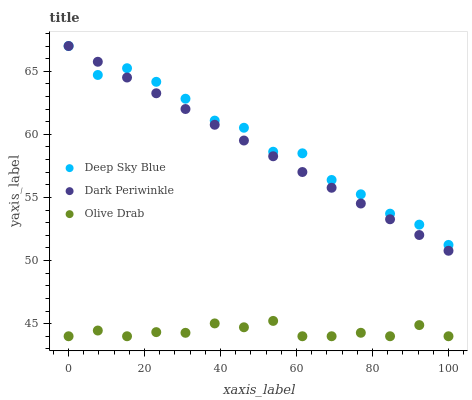Does Olive Drab have the minimum area under the curve?
Answer yes or no. Yes. Does Deep Sky Blue have the maximum area under the curve?
Answer yes or no. Yes. Does Dark Periwinkle have the minimum area under the curve?
Answer yes or no. No. Does Dark Periwinkle have the maximum area under the curve?
Answer yes or no. No. Is Dark Periwinkle the smoothest?
Answer yes or no. Yes. Is Deep Sky Blue the roughest?
Answer yes or no. Yes. Is Deep Sky Blue the smoothest?
Answer yes or no. No. Is Dark Periwinkle the roughest?
Answer yes or no. No. Does Olive Drab have the lowest value?
Answer yes or no. Yes. Does Dark Periwinkle have the lowest value?
Answer yes or no. No. Does Deep Sky Blue have the highest value?
Answer yes or no. Yes. Is Olive Drab less than Deep Sky Blue?
Answer yes or no. Yes. Is Dark Periwinkle greater than Olive Drab?
Answer yes or no. Yes. Does Deep Sky Blue intersect Dark Periwinkle?
Answer yes or no. Yes. Is Deep Sky Blue less than Dark Periwinkle?
Answer yes or no. No. Is Deep Sky Blue greater than Dark Periwinkle?
Answer yes or no. No. Does Olive Drab intersect Deep Sky Blue?
Answer yes or no. No. 